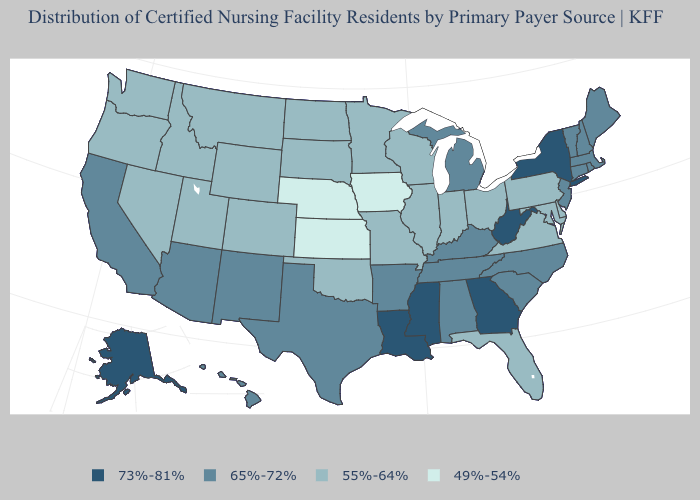Does California have the lowest value in the West?
Answer briefly. No. What is the value of Oregon?
Quick response, please. 55%-64%. Does Utah have a higher value than Kansas?
Quick response, please. Yes. Does Alaska have the lowest value in the West?
Quick response, please. No. Is the legend a continuous bar?
Give a very brief answer. No. Does Minnesota have the same value as Ohio?
Be succinct. Yes. Which states have the lowest value in the USA?
Keep it brief. Iowa, Kansas, Nebraska. Does Louisiana have the highest value in the South?
Quick response, please. Yes. Which states hav the highest value in the Northeast?
Short answer required. New York. What is the lowest value in states that border Connecticut?
Keep it brief. 65%-72%. Name the states that have a value in the range 55%-64%?
Concise answer only. Colorado, Delaware, Florida, Idaho, Illinois, Indiana, Maryland, Minnesota, Missouri, Montana, Nevada, North Dakota, Ohio, Oklahoma, Oregon, Pennsylvania, South Dakota, Utah, Virginia, Washington, Wisconsin, Wyoming. Which states have the lowest value in the South?
Give a very brief answer. Delaware, Florida, Maryland, Oklahoma, Virginia. What is the value of Vermont?
Answer briefly. 65%-72%. Does Montana have the highest value in the West?
Keep it brief. No. 